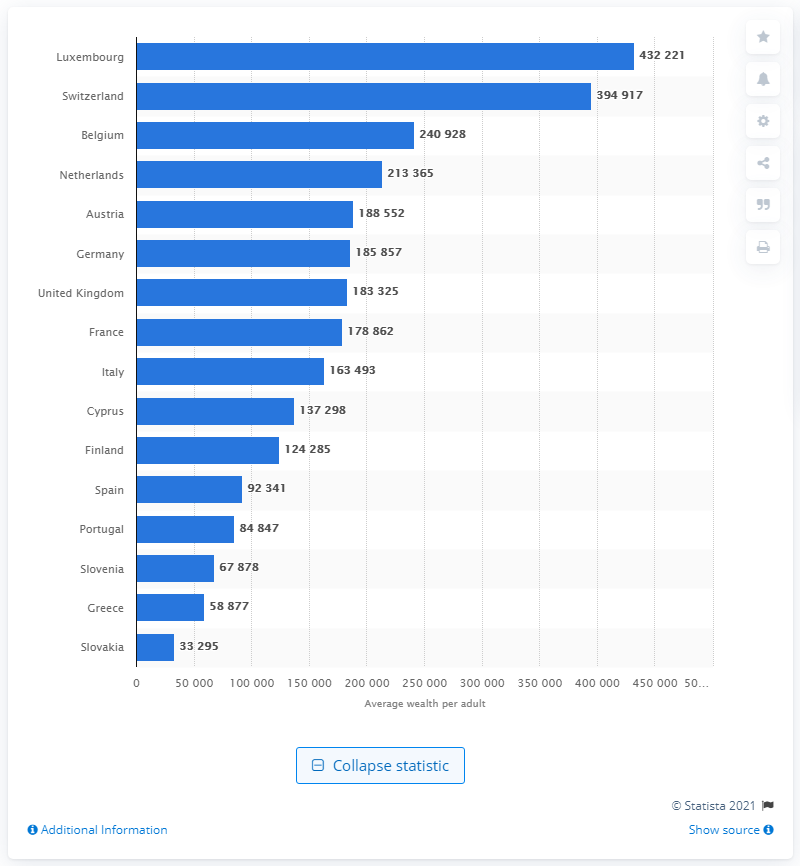Identify some key points in this picture. As of 2014, Luxembourg's wealth per adult was approximately 432,221 US dollars. According to statistics, the average wealth per adult in the UK is approximately 188,552. 